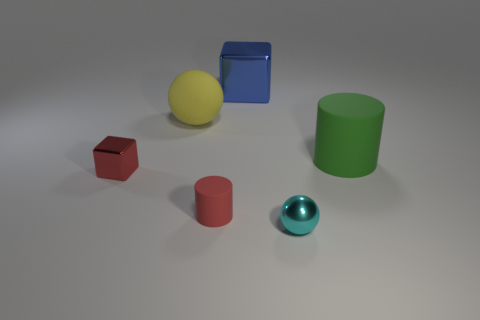Are there any other things that are the same size as the green object?
Your answer should be very brief. Yes. There is a shiny block that is behind the green rubber thing; does it have the same size as the large yellow matte ball?
Ensure brevity in your answer.  Yes. There is a cylinder that is on the left side of the cyan metal ball; what is its material?
Keep it short and to the point. Rubber. Is there any other thing that is the same shape as the tiny rubber object?
Offer a terse response. Yes. What number of metal objects are cylinders or large green cylinders?
Your answer should be compact. 0. Are there fewer large matte things in front of the yellow object than tiny yellow spheres?
Offer a terse response. No. What shape is the tiny metal object right of the rubber cylinder that is left of the rubber cylinder on the right side of the large blue metallic cube?
Your answer should be compact. Sphere. Does the small cylinder have the same color as the large rubber cylinder?
Give a very brief answer. No. Is the number of yellow things greater than the number of big cyan metal spheres?
Provide a succinct answer. Yes. What number of other things are the same material as the big yellow sphere?
Provide a succinct answer. 2. 